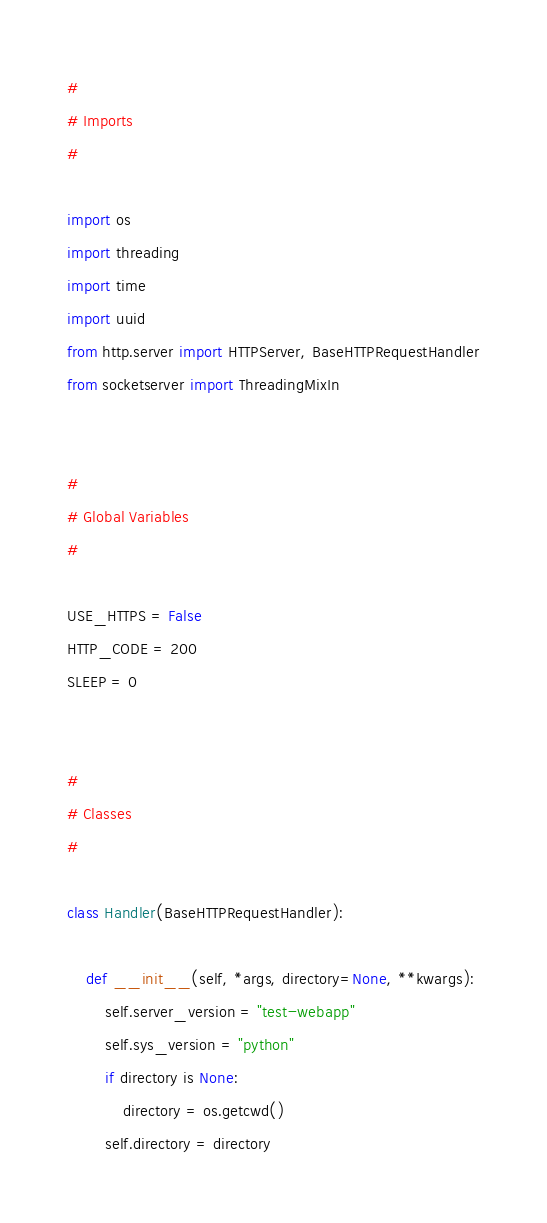Convert code to text. <code><loc_0><loc_0><loc_500><loc_500><_Python_>
#
# Imports
#

import os
import threading
import time
import uuid
from http.server import HTTPServer, BaseHTTPRequestHandler
from socketserver import ThreadingMixIn


#
# Global Variables
#

USE_HTTPS = False
HTTP_CODE = 200
SLEEP = 0


#
# Classes
#

class Handler(BaseHTTPRequestHandler):

    def __init__(self, *args, directory=None, **kwargs):
        self.server_version = "test-webapp"
        self.sys_version = "python"
        if directory is None:
            directory = os.getcwd()
        self.directory = directory</code> 